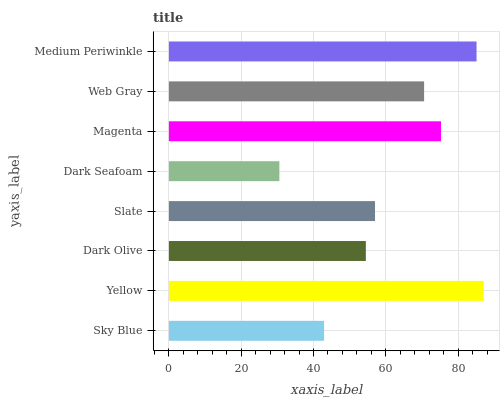Is Dark Seafoam the minimum?
Answer yes or no. Yes. Is Yellow the maximum?
Answer yes or no. Yes. Is Dark Olive the minimum?
Answer yes or no. No. Is Dark Olive the maximum?
Answer yes or no. No. Is Yellow greater than Dark Olive?
Answer yes or no. Yes. Is Dark Olive less than Yellow?
Answer yes or no. Yes. Is Dark Olive greater than Yellow?
Answer yes or no. No. Is Yellow less than Dark Olive?
Answer yes or no. No. Is Web Gray the high median?
Answer yes or no. Yes. Is Slate the low median?
Answer yes or no. Yes. Is Yellow the high median?
Answer yes or no. No. Is Dark Olive the low median?
Answer yes or no. No. 